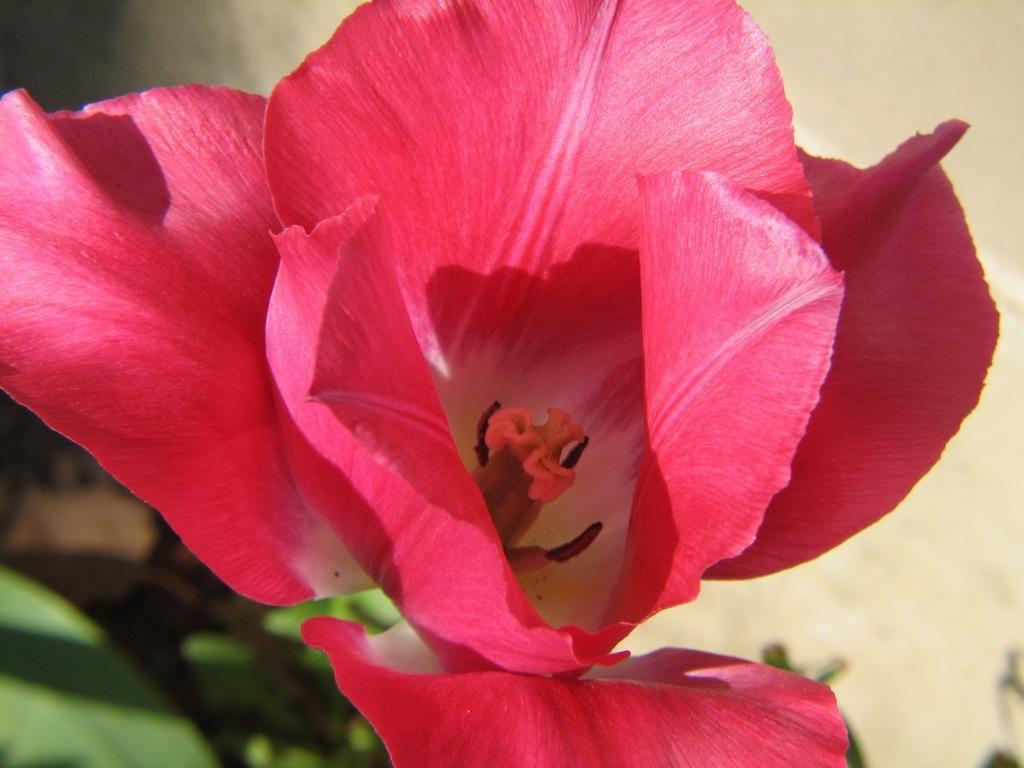Please provide a concise description of this image. In this image in the foreground there is flower, and in the background it looks like a wall and some plants. 